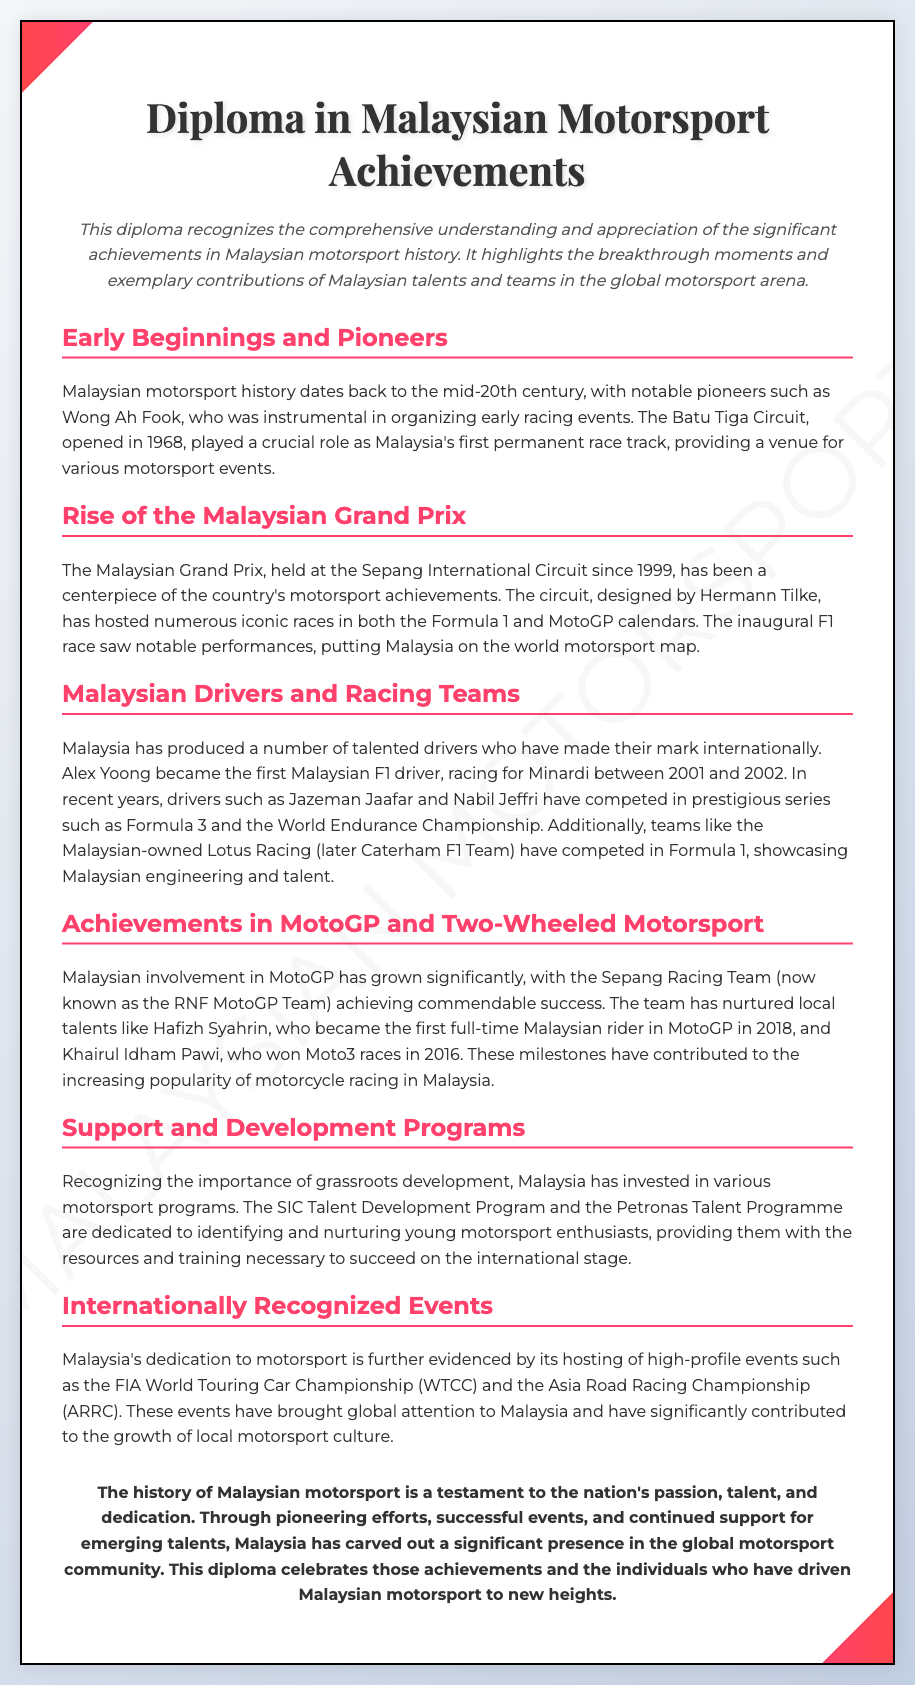what year did the Batu Tiga Circuit open? The Batu Tiga Circuit opened in 1968, marking an important milestone in Malaysian motorsport history.
Answer: 1968 who was the first Malaysian F1 driver? Alex Yoong is recognized as the first Malaysian F1 driver, making his debut between 2001 and 2002.
Answer: Alex Yoong what significant event began in 1999 in Malaysia? The inception of the Malaysian Grand Prix at the Sepang International Circuit in 1999 is a key event in the country's motorsport achievements.
Answer: Malaysian Grand Prix which team achieved success in MotoGP? The Sepang Racing Team (now RNF MotoGP Team) is noted for its commendable successes in the MotoGP arena.
Answer: Sepang Racing Team what program supports young Malaysian motorsport enthusiasts? The SIC Talent Development Program is one of the initiatives aimed at nurturing young talents in motorsport.
Answer: SIC Talent Development Program how many races did Khairul Idham Pawi win in Moto3? Khairul Idham Pawi achieved notable success by winning Moto3 races in 2016.
Answer: unspecified number who designed the Sepang International Circuit? Hermann Tilke was the designer of the Sepang International Circuit, enhancing its status as a prominent motorsport venue.
Answer: Hermann Tilke what is the conclusion about Malaysian motorsport? The diploma concludes that the history of Malaysian motorsport showcases the nation's passion, talent, and dedication.
Answer: passion, talent, and dedication 